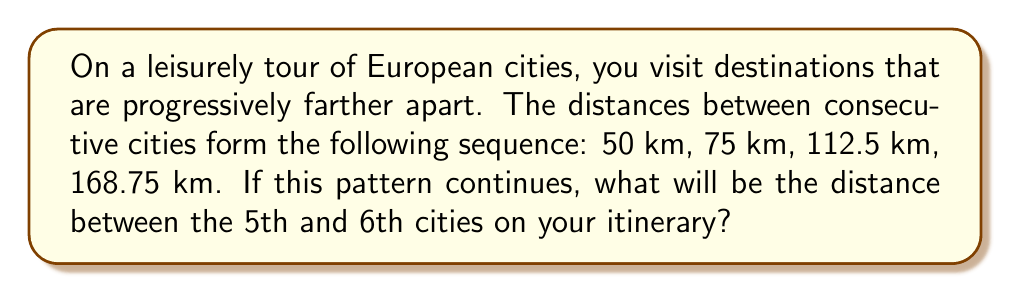Can you answer this question? Let's approach this step-by-step:

1) First, we need to identify the rule for the sequence. Let's look at the ratio between consecutive terms:

   $\frac{75}{50} = 1.5$
   $\frac{112.5}{75} = 1.5$
   $\frac{168.75}{112.5} = 1.5$

2) We can see that each term is 1.5 times the previous term. This is a geometric sequence with a common ratio of 1.5.

3) We can express this mathematically as:

   $a_n = a_1 \cdot r^{n-1}$

   Where $a_n$ is the nth term, $a_1$ is the first term (50), and $r$ is the common ratio (1.5).

4) We're asked about the distance between the 5th and 6th cities, which is the 5th term in our sequence.

5) Let's calculate the 5th term:

   $a_5 = 50 \cdot 1.5^{5-1} = 50 \cdot 1.5^4 = 50 \cdot 5.0625 = 253.125$

Therefore, the distance between the 5th and 6th cities will be 253.125 km.
Answer: 253.125 km 